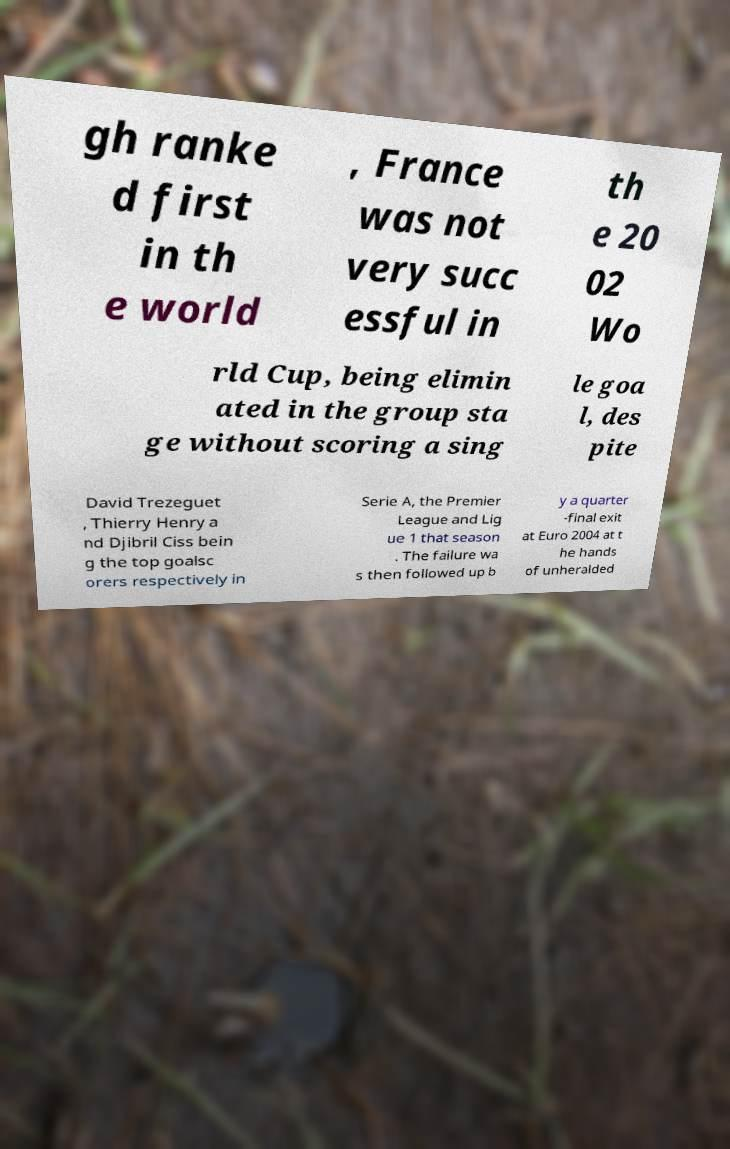Could you assist in decoding the text presented in this image and type it out clearly? gh ranke d first in th e world , France was not very succ essful in th e 20 02 Wo rld Cup, being elimin ated in the group sta ge without scoring a sing le goa l, des pite David Trezeguet , Thierry Henry a nd Djibril Ciss bein g the top goalsc orers respectively in Serie A, the Premier League and Lig ue 1 that season . The failure wa s then followed up b y a quarter -final exit at Euro 2004 at t he hands of unheralded 